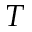Convert formula to latex. <formula><loc_0><loc_0><loc_500><loc_500>T</formula> 